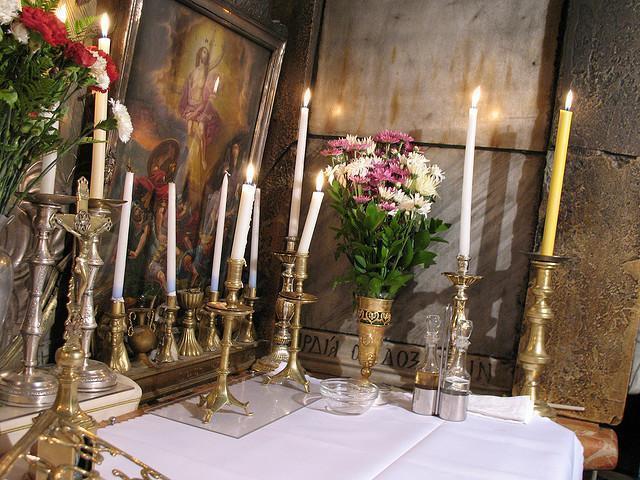What state are the candles in?
Choose the right answer from the provided options to respond to the question.
Options: Dowsed, lit, fake, unlit. Lit. 